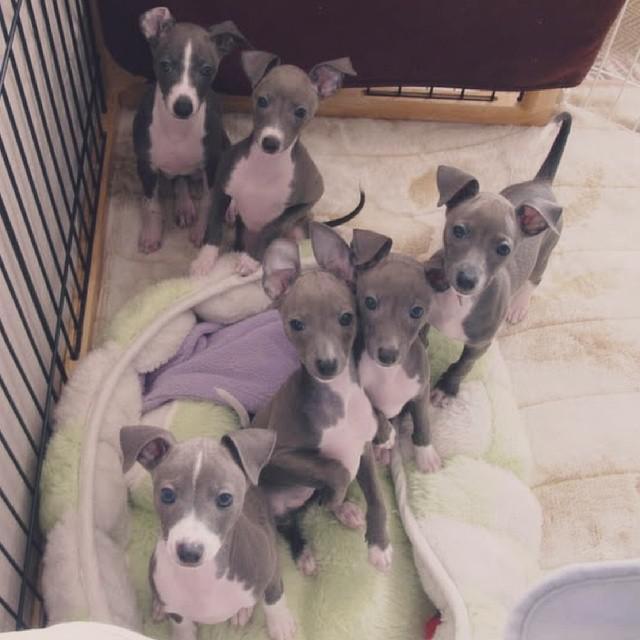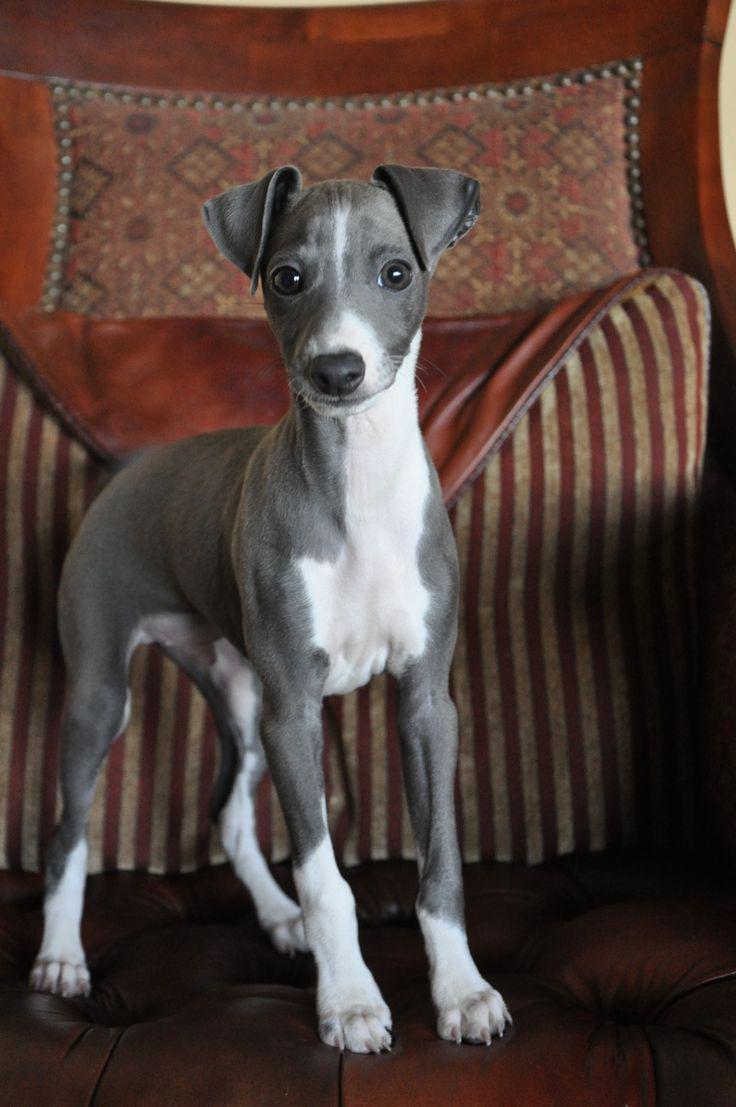The first image is the image on the left, the second image is the image on the right. Examine the images to the left and right. Is the description "The dog on the left is posing for the picture outside on a sunny day." accurate? Answer yes or no. No. The first image is the image on the left, the second image is the image on the right. Evaluate the accuracy of this statement regarding the images: "Each image contains exactly one dog, and the dog on the left is dark charcoal gray with white markings.". Is it true? Answer yes or no. No. 